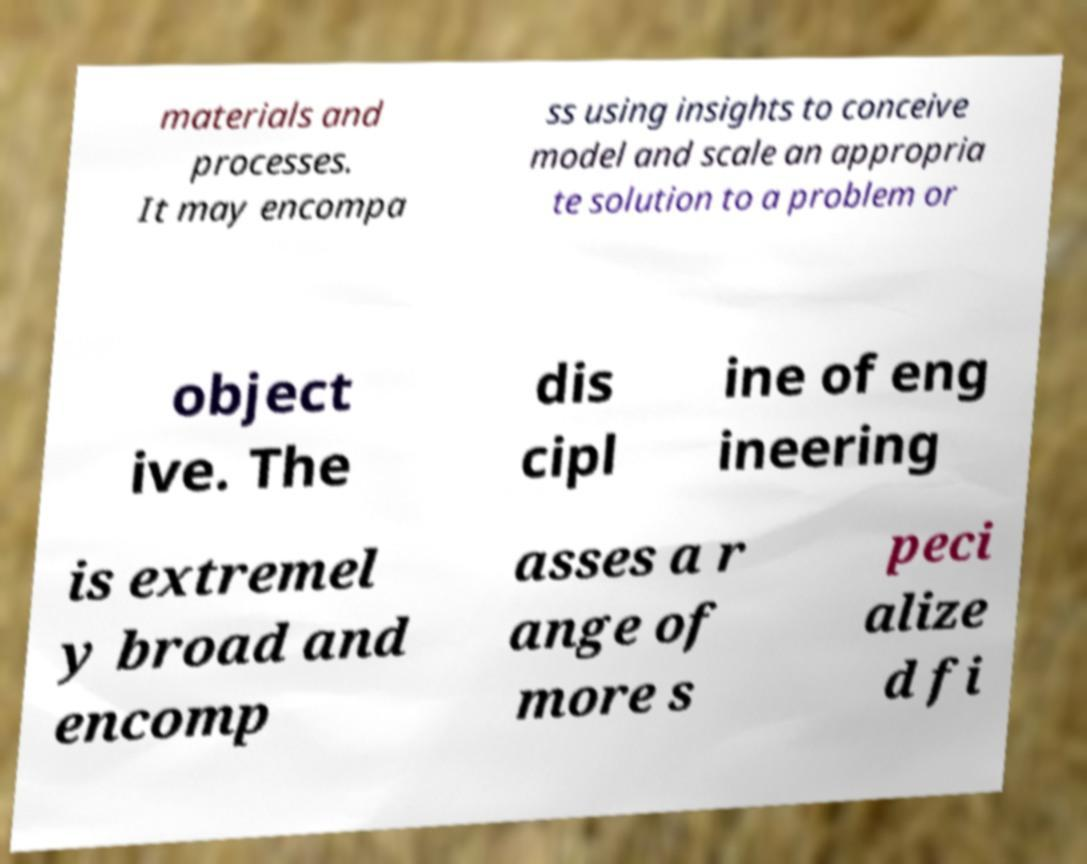For documentation purposes, I need the text within this image transcribed. Could you provide that? materials and processes. It may encompa ss using insights to conceive model and scale an appropria te solution to a problem or object ive. The dis cipl ine of eng ineering is extremel y broad and encomp asses a r ange of more s peci alize d fi 